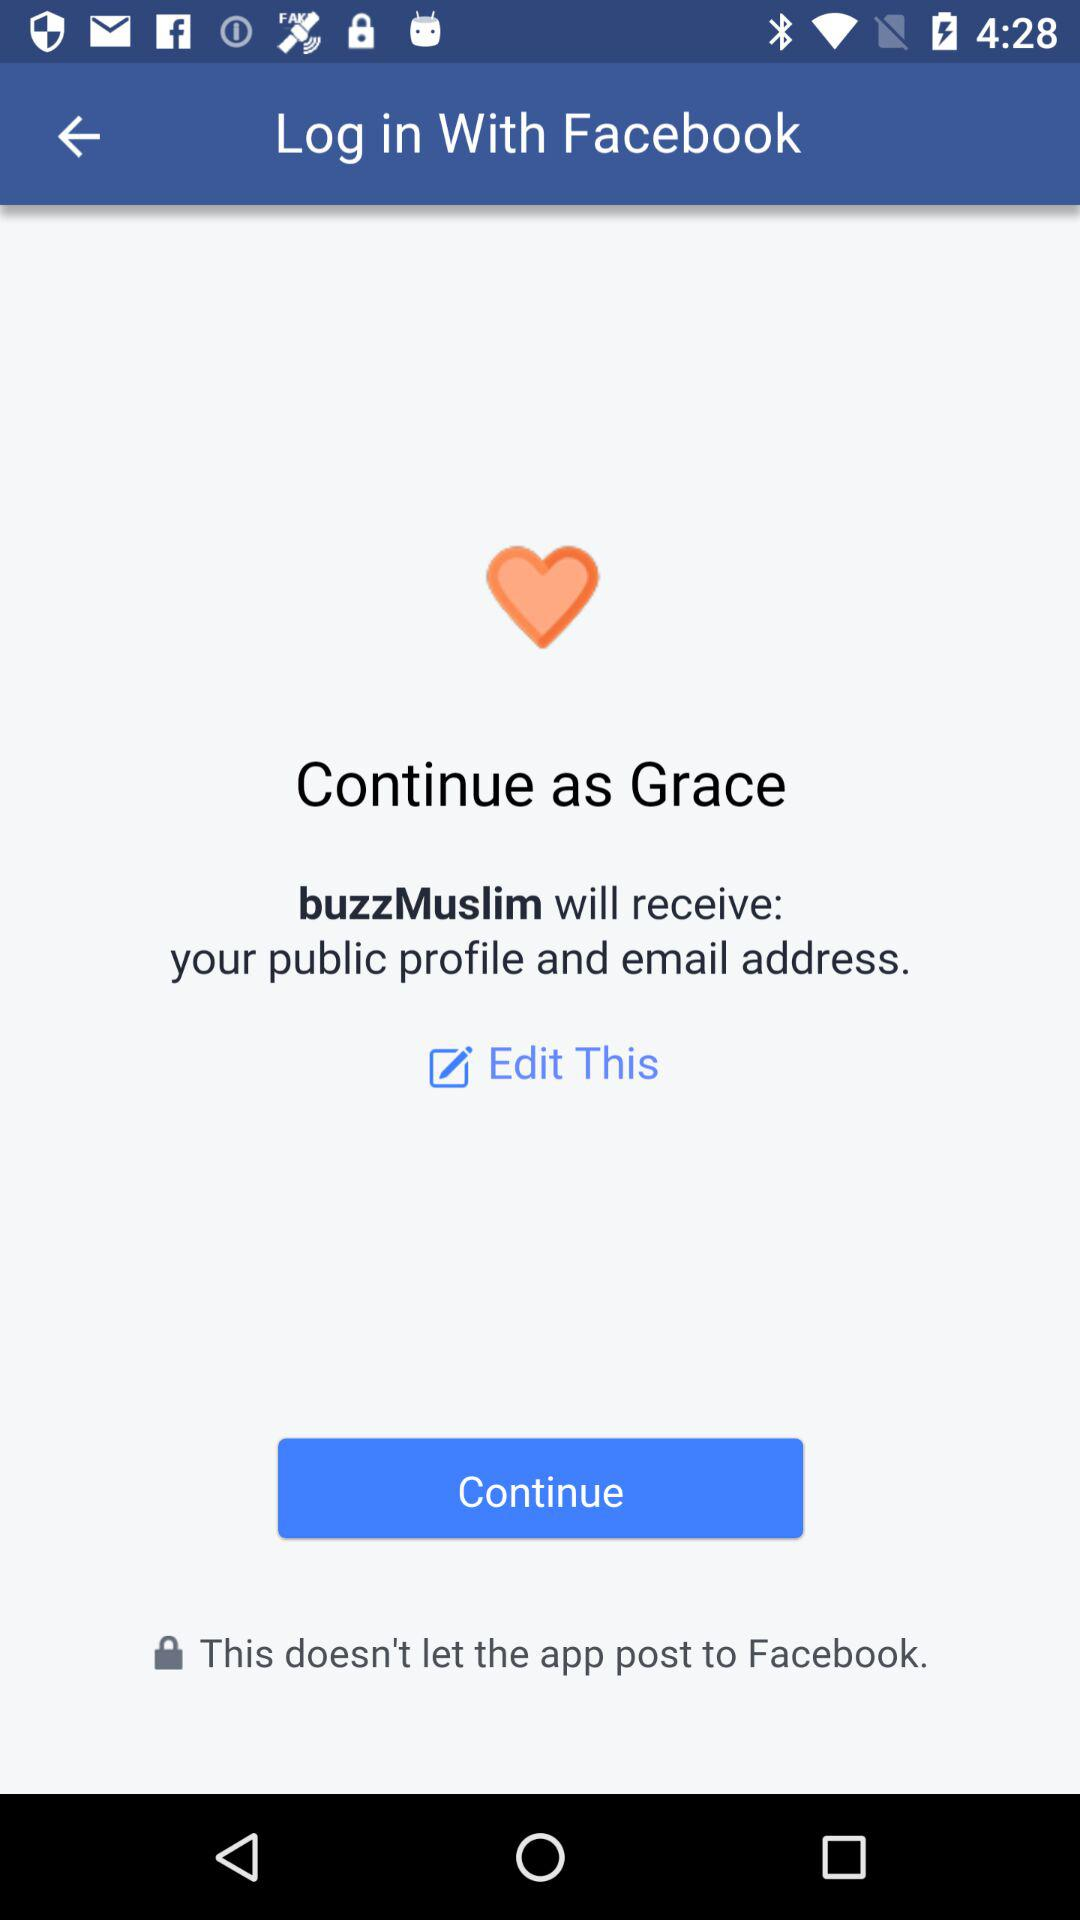What is the login name? The login name is "Grace". 